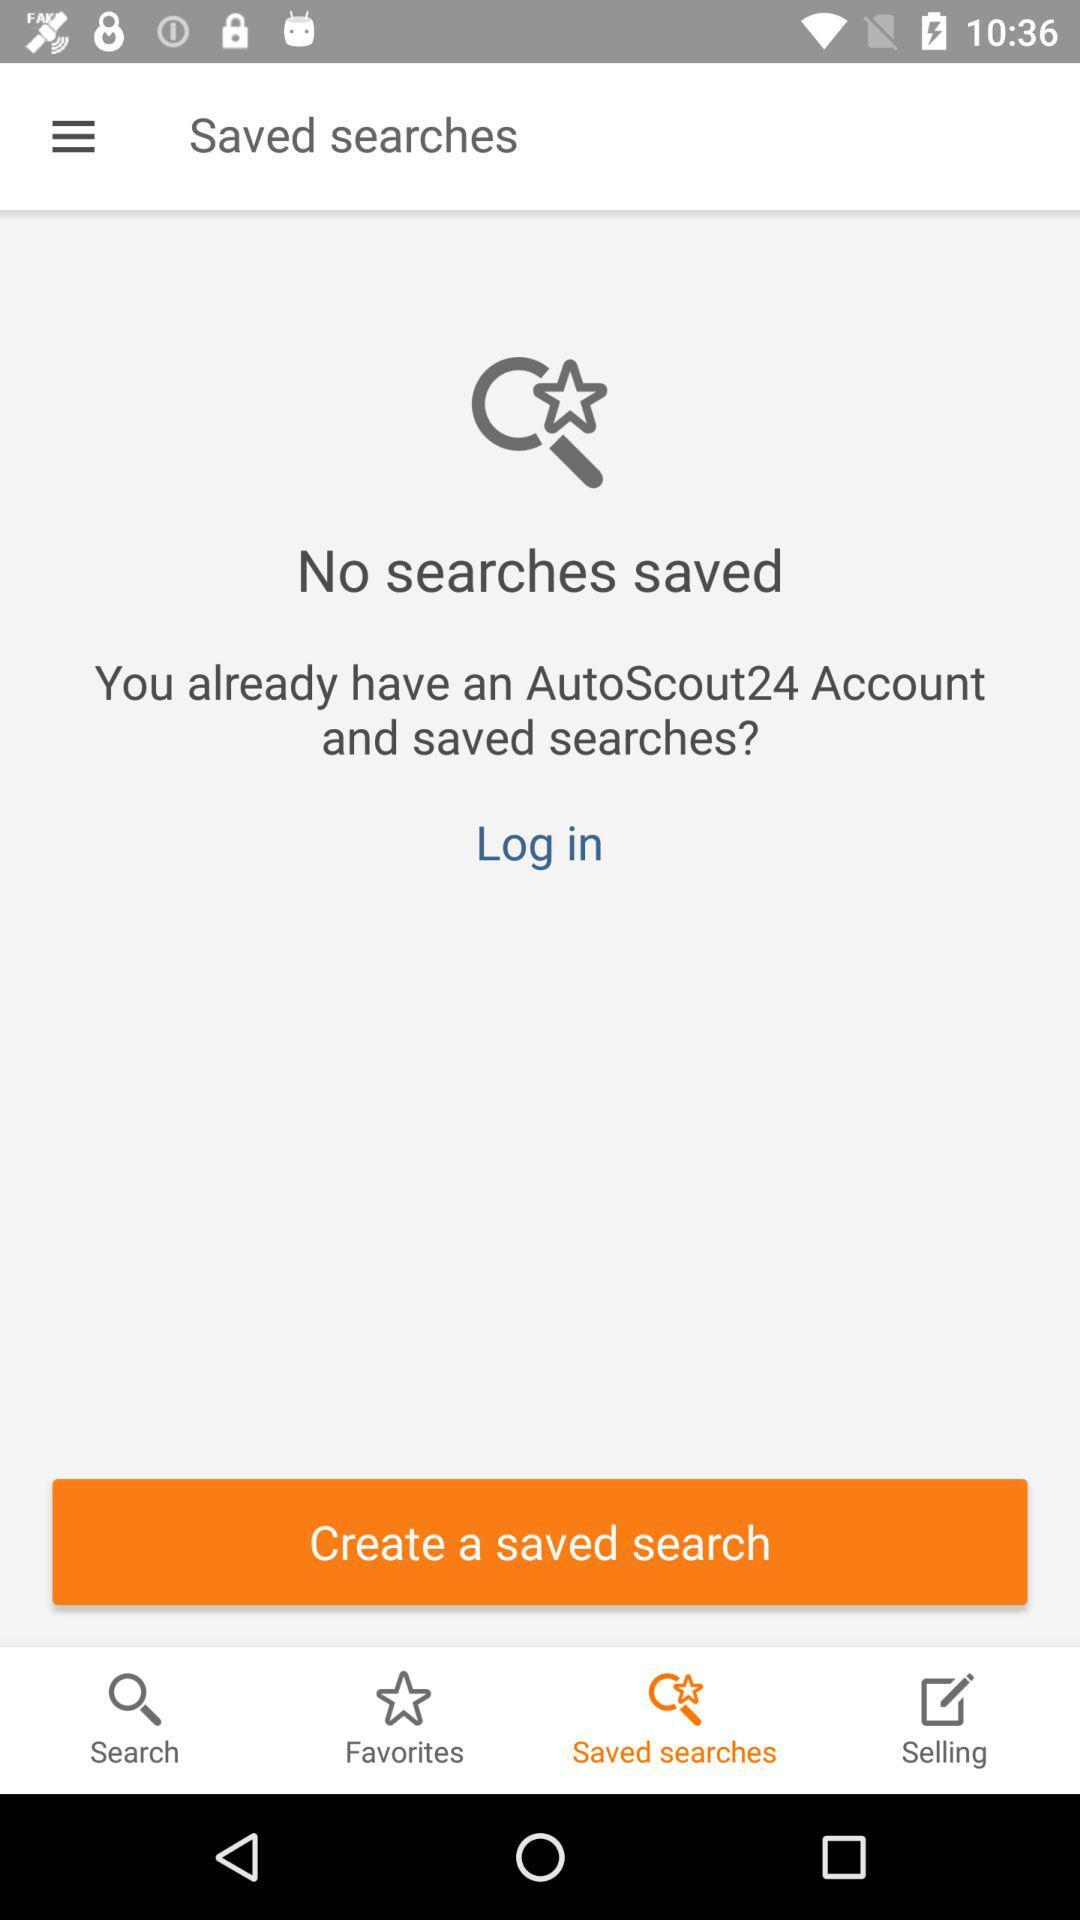How many saved searches does the user have?
Answer the question using a single word or phrase. 0 